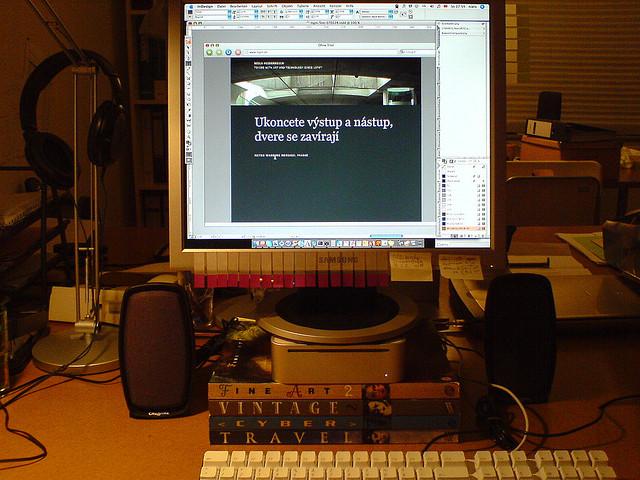Is the laptop?
Quick response, please. No. What is the TV monitor used for?
Give a very brief answer. Work. What is the last word on the plaque in front of the keyboard?
Quick response, please. Travel. What word is to the right of System?
Give a very brief answer. Vintage. How many cars are in the image?
Write a very short answer. 0. Is this a small monitor?
Short answer required. No. Is the television on a TV stand?
Concise answer only. No. Where are the headphones?
Give a very brief answer. On lamp. Are there speakers with this computer?
Answer briefly. Yes. 